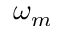<formula> <loc_0><loc_0><loc_500><loc_500>\omega _ { m }</formula> 